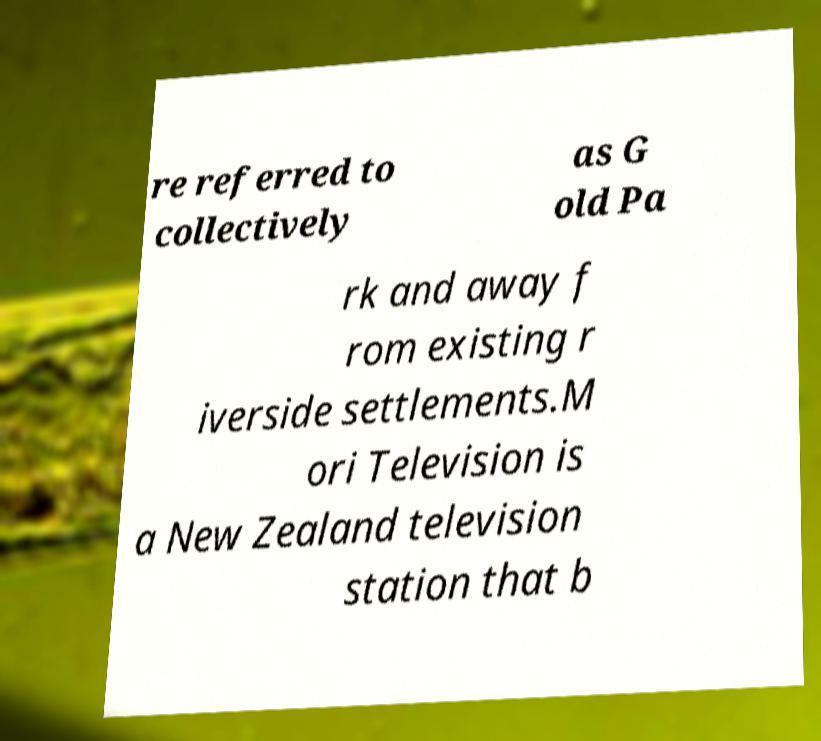Please read and relay the text visible in this image. What does it say? re referred to collectively as G old Pa rk and away f rom existing r iverside settlements.M ori Television is a New Zealand television station that b 